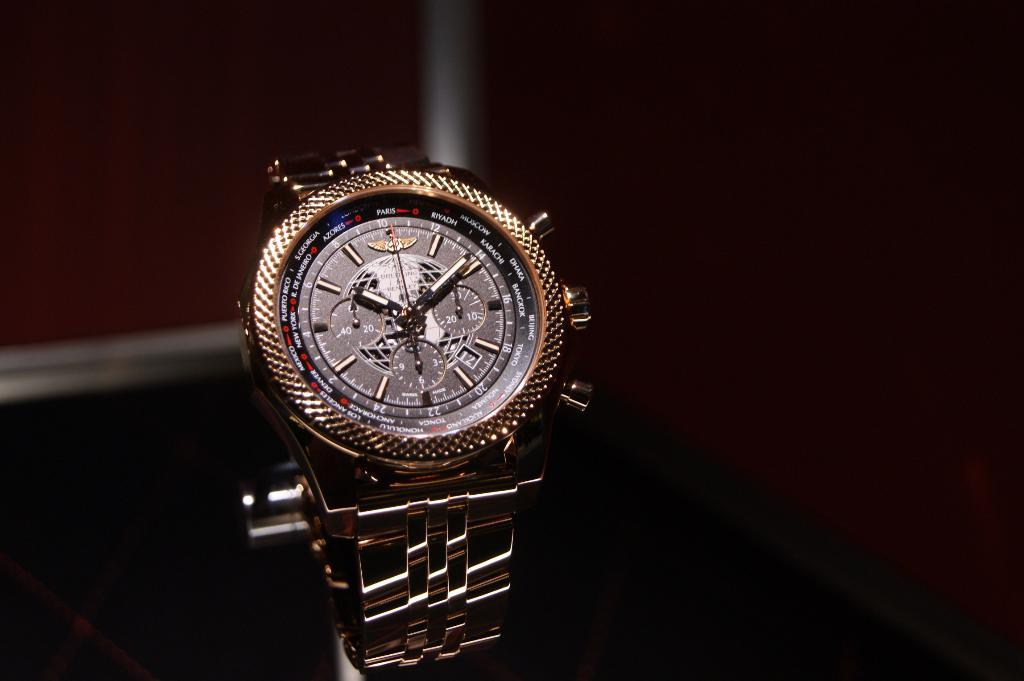<image>
Write a terse but informative summary of the picture. Gold wrist watch with a dial that says Azores, Rio De Janeiro and Paris among others. 